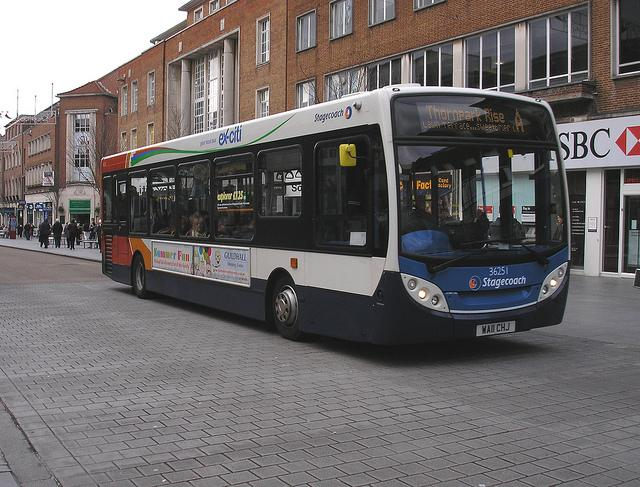What type street does this bus drive on? brick 